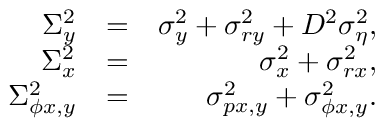<formula> <loc_0><loc_0><loc_500><loc_500>\begin{array} { r l r } { \Sigma _ { y } ^ { 2 } } & { = } & { \sigma _ { y } ^ { 2 } + \sigma _ { r y } ^ { 2 } + D ^ { 2 } \sigma _ { \eta } ^ { 2 } , } \\ { \Sigma _ { x } ^ { 2 } } & { = } & { \sigma _ { x } ^ { 2 } + \sigma _ { r x } ^ { 2 } , } \\ { \Sigma _ { \phi x , y } ^ { 2 } } & { = } & { \sigma _ { p x , y } ^ { 2 } + \sigma _ { \phi x , y } ^ { 2 } . } \end{array}</formula> 